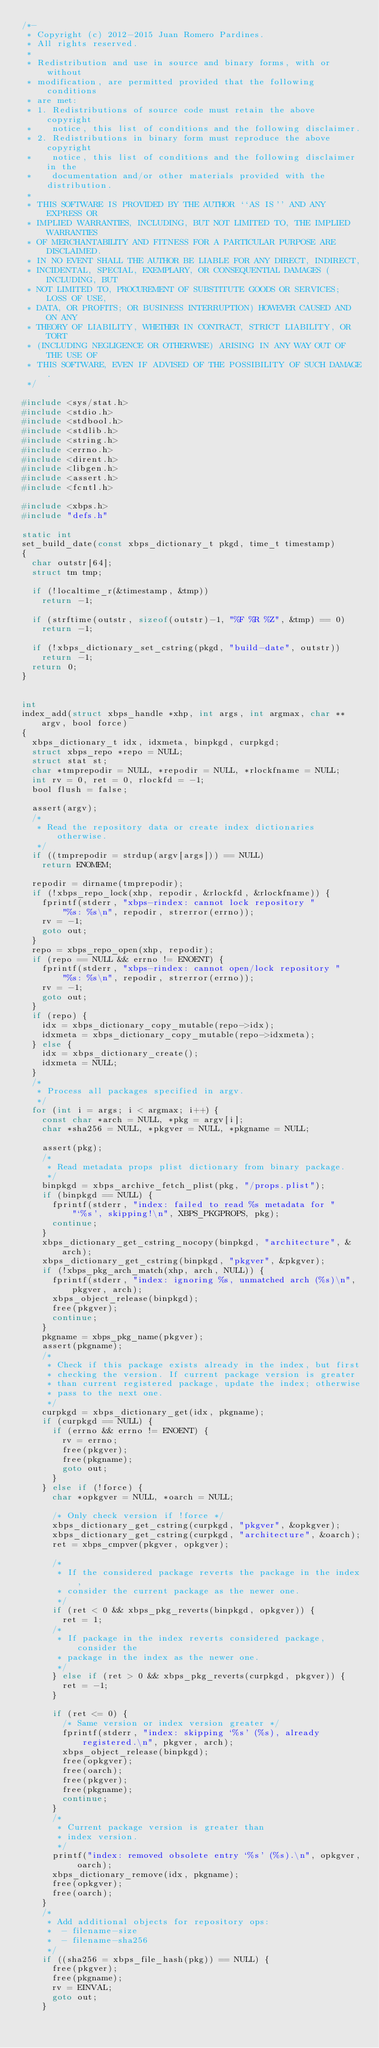<code> <loc_0><loc_0><loc_500><loc_500><_C_>/*-
 * Copyright (c) 2012-2015 Juan Romero Pardines.
 * All rights reserved.
 *
 * Redistribution and use in source and binary forms, with or without
 * modification, are permitted provided that the following conditions
 * are met:
 * 1. Redistributions of source code must retain the above copyright
 *    notice, this list of conditions and the following disclaimer.
 * 2. Redistributions in binary form must reproduce the above copyright
 *    notice, this list of conditions and the following disclaimer in the
 *    documentation and/or other materials provided with the distribution.
 *
 * THIS SOFTWARE IS PROVIDED BY THE AUTHOR ``AS IS'' AND ANY EXPRESS OR
 * IMPLIED WARRANTIES, INCLUDING, BUT NOT LIMITED TO, THE IMPLIED WARRANTIES
 * OF MERCHANTABILITY AND FITNESS FOR A PARTICULAR PURPOSE ARE DISCLAIMED.
 * IN NO EVENT SHALL THE AUTHOR BE LIABLE FOR ANY DIRECT, INDIRECT,
 * INCIDENTAL, SPECIAL, EXEMPLARY, OR CONSEQUENTIAL DAMAGES (INCLUDING, BUT
 * NOT LIMITED TO, PROCUREMENT OF SUBSTITUTE GOODS OR SERVICES; LOSS OF USE,
 * DATA, OR PROFITS; OR BUSINESS INTERRUPTION) HOWEVER CAUSED AND ON ANY
 * THEORY OF LIABILITY, WHETHER IN CONTRACT, STRICT LIABILITY, OR TORT
 * (INCLUDING NEGLIGENCE OR OTHERWISE) ARISING IN ANY WAY OUT OF THE USE OF
 * THIS SOFTWARE, EVEN IF ADVISED OF THE POSSIBILITY OF SUCH DAMAGE.
 */

#include <sys/stat.h>
#include <stdio.h>
#include <stdbool.h>
#include <stdlib.h>
#include <string.h>
#include <errno.h>
#include <dirent.h>
#include <libgen.h>
#include <assert.h>
#include <fcntl.h>

#include <xbps.h>
#include "defs.h"

static int
set_build_date(const xbps_dictionary_t pkgd, time_t timestamp)
{
	char outstr[64];
	struct tm tmp;

	if (!localtime_r(&timestamp, &tmp))
		return -1;

	if (strftime(outstr, sizeof(outstr)-1, "%F %R %Z", &tmp) == 0)
		return -1;

	if (!xbps_dictionary_set_cstring(pkgd, "build-date", outstr))
		return -1;
	return 0;
}


int
index_add(struct xbps_handle *xhp, int args, int argmax, char **argv, bool force)
{
	xbps_dictionary_t idx, idxmeta, binpkgd, curpkgd;
	struct xbps_repo *repo = NULL;
	struct stat st;
	char *tmprepodir = NULL, *repodir = NULL, *rlockfname = NULL;
	int rv = 0, ret = 0, rlockfd = -1;
	bool flush = false;

	assert(argv);
	/*
	 * Read the repository data or create index dictionaries otherwise.
	 */
	if ((tmprepodir = strdup(argv[args])) == NULL)
		return ENOMEM;

	repodir = dirname(tmprepodir);
	if (!xbps_repo_lock(xhp, repodir, &rlockfd, &rlockfname)) {
		fprintf(stderr, "xbps-rindex: cannot lock repository "
		    "%s: %s\n", repodir, strerror(errno));
		rv = -1;
		goto out;
	}
	repo = xbps_repo_open(xhp, repodir);
	if (repo == NULL && errno != ENOENT) {
		fprintf(stderr, "xbps-rindex: cannot open/lock repository "
		    "%s: %s\n", repodir, strerror(errno));
		rv = -1;
		goto out;
	}
	if (repo) {
		idx = xbps_dictionary_copy_mutable(repo->idx);
		idxmeta = xbps_dictionary_copy_mutable(repo->idxmeta);
	} else {
		idx = xbps_dictionary_create();
		idxmeta = NULL;
	}
	/*
	 * Process all packages specified in argv.
	 */
	for (int i = args; i < argmax; i++) {
		const char *arch = NULL, *pkg = argv[i];
		char *sha256 = NULL, *pkgver = NULL, *pkgname = NULL;

		assert(pkg);
		/*
		 * Read metadata props plist dictionary from binary package.
		 */
		binpkgd = xbps_archive_fetch_plist(pkg, "/props.plist");
		if (binpkgd == NULL) {
			fprintf(stderr, "index: failed to read %s metadata for "
			    "`%s', skipping!\n", XBPS_PKGPROPS, pkg);
			continue;
		}
		xbps_dictionary_get_cstring_nocopy(binpkgd, "architecture", &arch);
		xbps_dictionary_get_cstring(binpkgd, "pkgver", &pkgver);
		if (!xbps_pkg_arch_match(xhp, arch, NULL)) {
			fprintf(stderr, "index: ignoring %s, unmatched arch (%s)\n", pkgver, arch);
			xbps_object_release(binpkgd);
			free(pkgver);
			continue;
		}
		pkgname = xbps_pkg_name(pkgver);
		assert(pkgname);
		/*
		 * Check if this package exists already in the index, but first
		 * checking the version. If current package version is greater
		 * than current registered package, update the index; otherwise
		 * pass to the next one.
		 */
		curpkgd = xbps_dictionary_get(idx, pkgname);
		if (curpkgd == NULL) {
			if (errno && errno != ENOENT) {
				rv = errno;
				free(pkgver);
				free(pkgname);
				goto out;
			}
		} else if (!force) {
			char *opkgver = NULL, *oarch = NULL;

			/* Only check version if !force */
			xbps_dictionary_get_cstring(curpkgd, "pkgver", &opkgver);
			xbps_dictionary_get_cstring(curpkgd, "architecture", &oarch);
			ret = xbps_cmpver(pkgver, opkgver);

			/*
			 * If the considered package reverts the package in the index,
			 * consider the current package as the newer one.
			 */
			if (ret < 0 && xbps_pkg_reverts(binpkgd, opkgver)) {
				ret = 1;
			/*
			 * If package in the index reverts considered package, consider the
			 * package in the index as the newer one.
			 */
			} else if (ret > 0 && xbps_pkg_reverts(curpkgd, pkgver)) {
				ret = -1;
			}

			if (ret <= 0) {
				/* Same version or index version greater */
				fprintf(stderr, "index: skipping `%s' (%s), already registered.\n", pkgver, arch);
				xbps_object_release(binpkgd);
				free(opkgver);
				free(oarch);
				free(pkgver);
				free(pkgname);
				continue;
			}
			/*
			 * Current package version is greater than
			 * index version.
			 */
			printf("index: removed obsolete entry `%s' (%s).\n", opkgver, oarch);
			xbps_dictionary_remove(idx, pkgname);
			free(opkgver);
			free(oarch);
		}
		/*
		 * Add additional objects for repository ops:
		 * 	- filename-size
		 * 	- filename-sha256
		 */
		if ((sha256 = xbps_file_hash(pkg)) == NULL) {
			free(pkgver);
			free(pkgname);
			rv = EINVAL;
			goto out;
		}</code> 